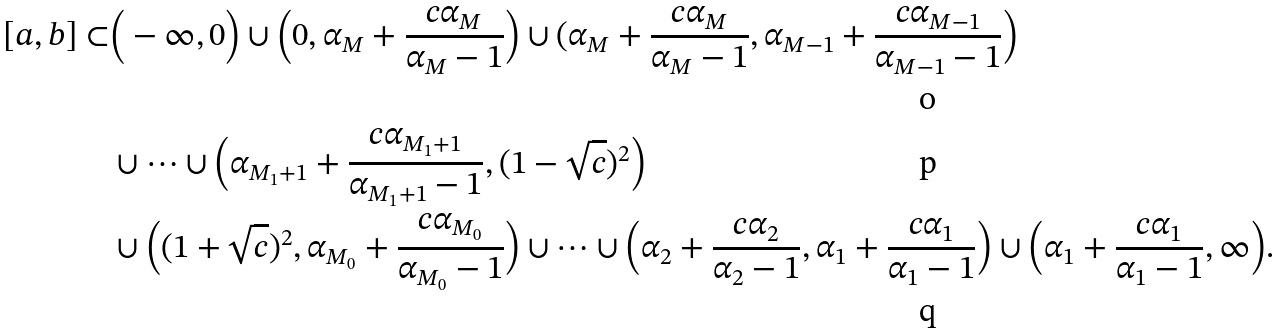<formula> <loc_0><loc_0><loc_500><loc_500>[ a , b ] \subset & \Big ( - \infty , 0 \Big ) \cup \Big ( 0 , \alpha _ { M } + \frac { c \alpha _ { M } } { \alpha _ { M } - 1 } \Big ) \cup ( \alpha _ { M } + \frac { c \alpha _ { M } } { \alpha _ { M } - 1 } , \alpha _ { M - 1 } + \frac { c \alpha _ { M - 1 } } { \alpha _ { M - 1 } - 1 } \Big ) \\ & \cup \dots \cup \Big ( \alpha _ { M _ { 1 } + 1 } + \frac { c \alpha _ { M _ { 1 } + 1 } } { \alpha _ { M _ { 1 } + 1 } - 1 } , ( 1 - \sqrt { c } ) ^ { 2 } \Big ) \\ & \cup \Big ( ( 1 + \sqrt { c } ) ^ { 2 } , \alpha _ { M _ { 0 } } + \frac { c \alpha _ { M _ { 0 } } } { \alpha _ { M _ { 0 } } - 1 } \Big ) \cup \dots \cup \Big ( \alpha _ { 2 } + \frac { c \alpha _ { 2 } } { \alpha _ { 2 } - 1 } , \alpha _ { 1 } + \frac { c \alpha _ { 1 } } { \alpha _ { 1 } - 1 } \Big ) \cup \Big ( \alpha _ { 1 } + \frac { c \alpha _ { 1 } } { \alpha _ { 1 } - 1 } , \infty \Big ) .</formula> 